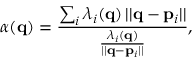<formula> <loc_0><loc_0><loc_500><loc_500>\alpha ( { q } ) = \frac { \sum _ { i } \lambda _ { i } ( { q } ) \, | | { q } - { p } _ { i } | | } { \frac { \lambda _ { i } ( { q } ) } { | | { q } - { p } _ { i } | | } } ,</formula> 